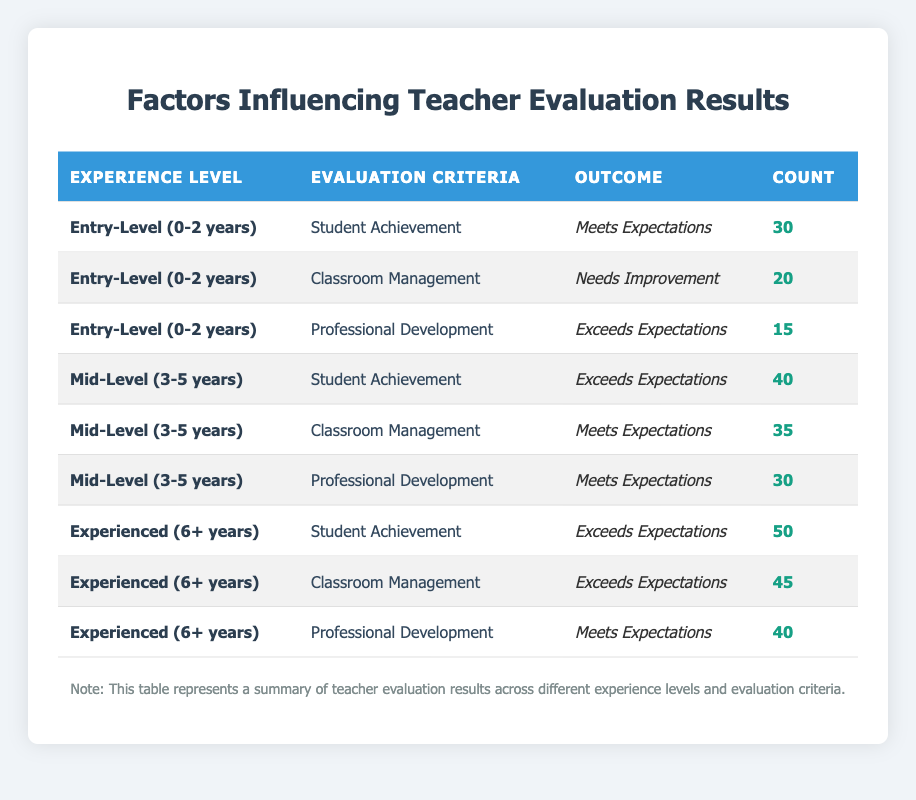What is the count of teachers in the Entry-Level category who Exceed Expectations in Professional Development? Looking at the table, there is only one entry for Entry-Level teachers in the Professional Development category, which lists the outcome as Exceeds Expectations with a count of 15.
Answer: 15 How many teachers in the Mid-Level category need improvement in Classroom Management? In the table, under Mid-Level for Classroom Management, the Outcome is listed as Needs Improvement, but it is not present in the Mid-Level section; therefore, the count is zero.
Answer: 0 What is the total count of teachers evaluated for Student Achievement across all experience levels? To find the total count for Student Achievement, I sum the values from each experience level: 30 (Entry-Level) + 40 (Mid-Level) + 50 (Experienced) = 120.
Answer: 120 How many teachers meet expectations in both Professional Development and Classroom Management across all experience levels? From the table, I identify counts for both criteria: Classroom Management: 35 (Mid-Level) + 40 (Experienced) and Professional Development: 15 (Entry-Level) + 30 (Mid-Level) + 40 (Experienced). Adding these up gives 35 + 40 + 15 + 30 + 40 = 150.
Answer: 150 Is it true that all teachers with 6+ years of experience exceed expectations in Classroom Management? In the table, it shows that experienced teachers have a count of 45 for Classroom Management with an outcome of Exceeds Expectations, confirming that it is true for this category.
Answer: True What is the average number of teachers who meet expectations for all categories across Entry-Level and Mid-Level combined? For Entry-Level: 30 (Student Achievement) + 0 (Classroom Management, Needs Improvement) + 15 (Professional Development) = 45, and for Mid-Level: 40 (Student Achievement) + 35 (Classroom Management) + 30 (Professional Development) = 105. Combined, 45 + 105 = 150 for two group averages gives 150 / 5 = 30.
Answer: 30 Which Evaluation Criteria had the highest count of teachers exceeding expectations in the Experienced category? Examining the Experienced row, both Student Achievement and Classroom Management have counts of 50 and 45 respectively. Therefore, Student Achievement has the highest count, at 50.
Answer: 50 What is the difference in counts of teachers between those who Exceed Expectations and those who Need Improvement in Classroom Management across all experience levels? For Classroom Management, there are counts of 0 (Entry-Level), 35 (Mid-Level, Meets Expectations), and 45 (Experienced, Exceeds Expectations). The total count exceeding expectations is 45 and the needs improvement is 0, so the difference is 45 - 0 = 45.
Answer: 45 